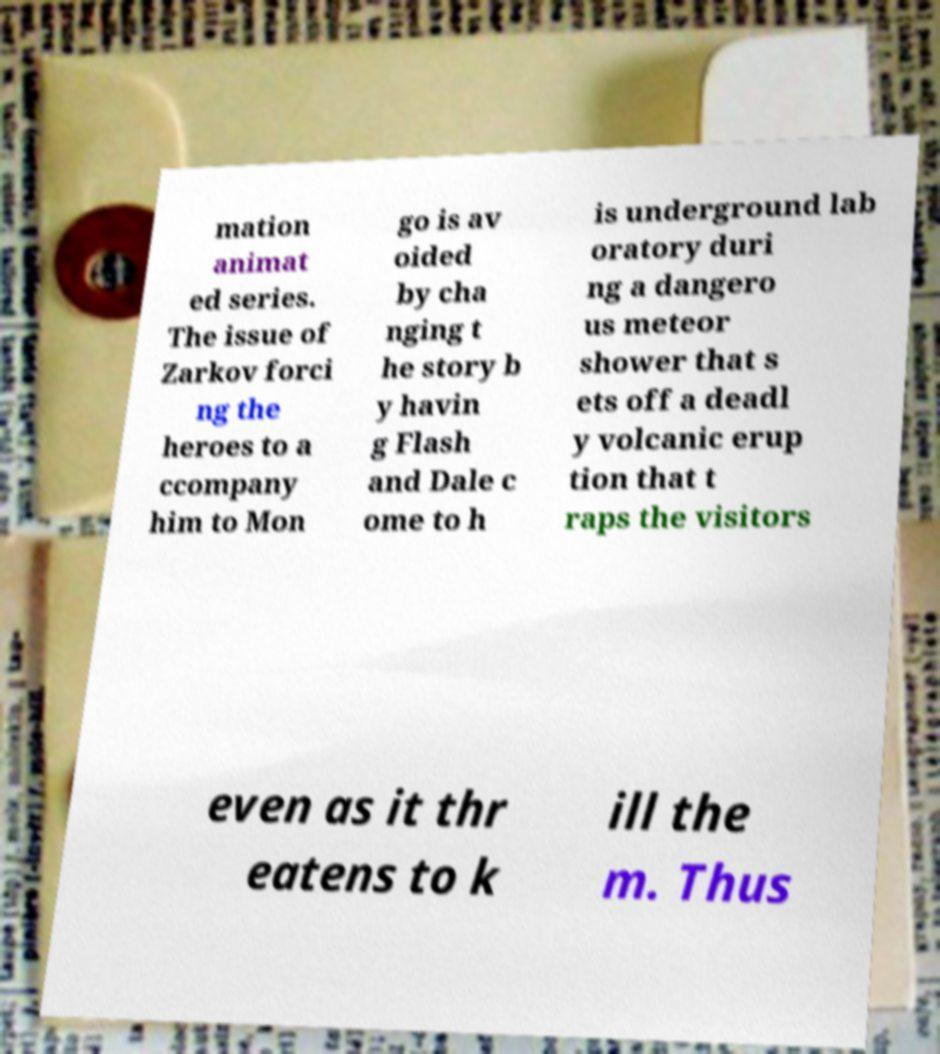Could you extract and type out the text from this image? mation animat ed series. The issue of Zarkov forci ng the heroes to a ccompany him to Mon go is av oided by cha nging t he story b y havin g Flash and Dale c ome to h is underground lab oratory duri ng a dangero us meteor shower that s ets off a deadl y volcanic erup tion that t raps the visitors even as it thr eatens to k ill the m. Thus 